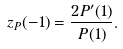Convert formula to latex. <formula><loc_0><loc_0><loc_500><loc_500>z _ { P } ( - 1 ) = \frac { 2 P ^ { \prime } ( 1 ) } { P ( 1 ) } .</formula> 